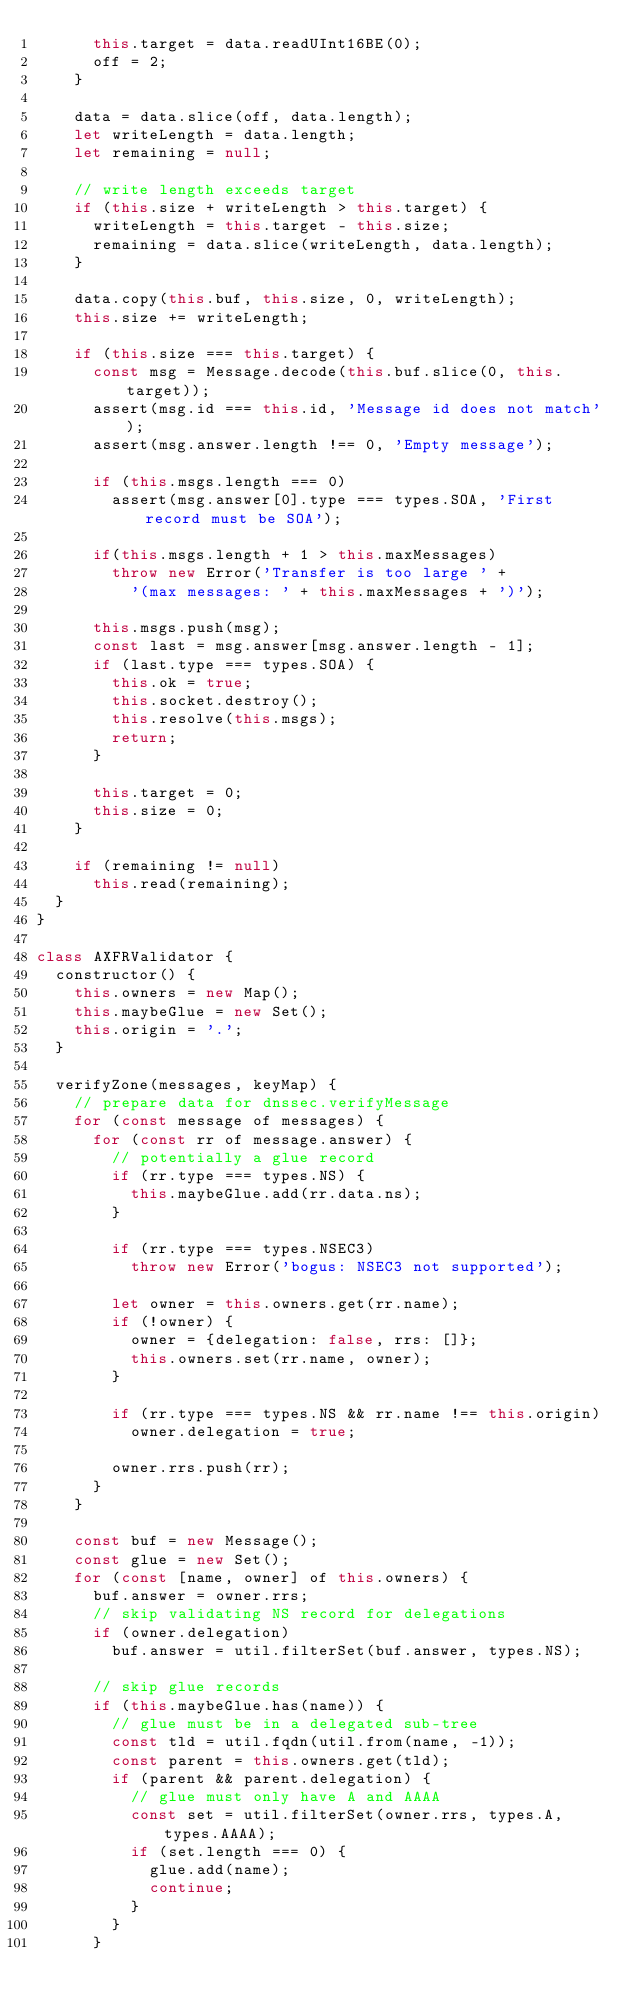Convert code to text. <code><loc_0><loc_0><loc_500><loc_500><_JavaScript_>      this.target = data.readUInt16BE(0);
      off = 2;
    }

    data = data.slice(off, data.length);
    let writeLength = data.length;
    let remaining = null;

    // write length exceeds target
    if (this.size + writeLength > this.target) {
      writeLength = this.target - this.size;
      remaining = data.slice(writeLength, data.length);
    }

    data.copy(this.buf, this.size, 0, writeLength);
    this.size += writeLength;

    if (this.size === this.target) {
      const msg = Message.decode(this.buf.slice(0, this.target));
      assert(msg.id === this.id, 'Message id does not match');
      assert(msg.answer.length !== 0, 'Empty message');

      if (this.msgs.length === 0)
        assert(msg.answer[0].type === types.SOA, 'First record must be SOA');

      if(this.msgs.length + 1 > this.maxMessages)
        throw new Error('Transfer is too large ' +
          '(max messages: ' + this.maxMessages + ')');

      this.msgs.push(msg);
      const last = msg.answer[msg.answer.length - 1];
      if (last.type === types.SOA) {
        this.ok = true;
        this.socket.destroy();
        this.resolve(this.msgs);
        return;
      }

      this.target = 0;
      this.size = 0;
    }

    if (remaining != null)
      this.read(remaining);
  }
}

class AXFRValidator {
  constructor() {
    this.owners = new Map();
    this.maybeGlue = new Set();
    this.origin = '.';
  }

  verifyZone(messages, keyMap) {
    // prepare data for dnssec.verifyMessage
    for (const message of messages) {
      for (const rr of message.answer) {
        // potentially a glue record
        if (rr.type === types.NS) {
          this.maybeGlue.add(rr.data.ns);
        }

        if (rr.type === types.NSEC3)
          throw new Error('bogus: NSEC3 not supported');

        let owner = this.owners.get(rr.name);
        if (!owner) {
          owner = {delegation: false, rrs: []};
          this.owners.set(rr.name, owner);
        }

        if (rr.type === types.NS && rr.name !== this.origin)
          owner.delegation = true;

        owner.rrs.push(rr);
      }
    }

    const buf = new Message();
    const glue = new Set();
    for (const [name, owner] of this.owners) {
      buf.answer = owner.rrs;
      // skip validating NS record for delegations
      if (owner.delegation)
        buf.answer = util.filterSet(buf.answer, types.NS);

      // skip glue records
      if (this.maybeGlue.has(name)) {
        // glue must be in a delegated sub-tree
        const tld = util.fqdn(util.from(name, -1));
        const parent = this.owners.get(tld);
        if (parent && parent.delegation) {
          // glue must only have A and AAAA
          const set = util.filterSet(owner.rrs, types.A, types.AAAA);
          if (set.length === 0) {
            glue.add(name);
            continue;
          }
        }
      }
</code> 